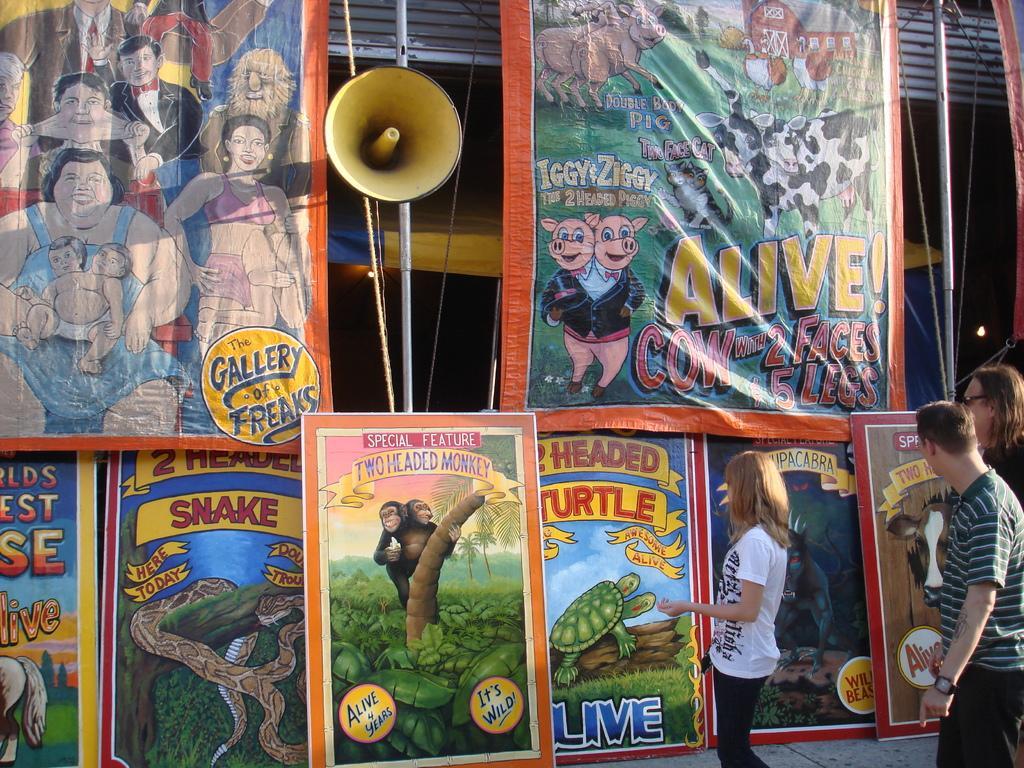Could you give a brief overview of what you see in this image? In this image I can see banners and posters. I can also see some cartoon images of people, animals, trees and other objects on this banners and posters. Here I can see some object, poles, ropes and people are standing on the ground. 